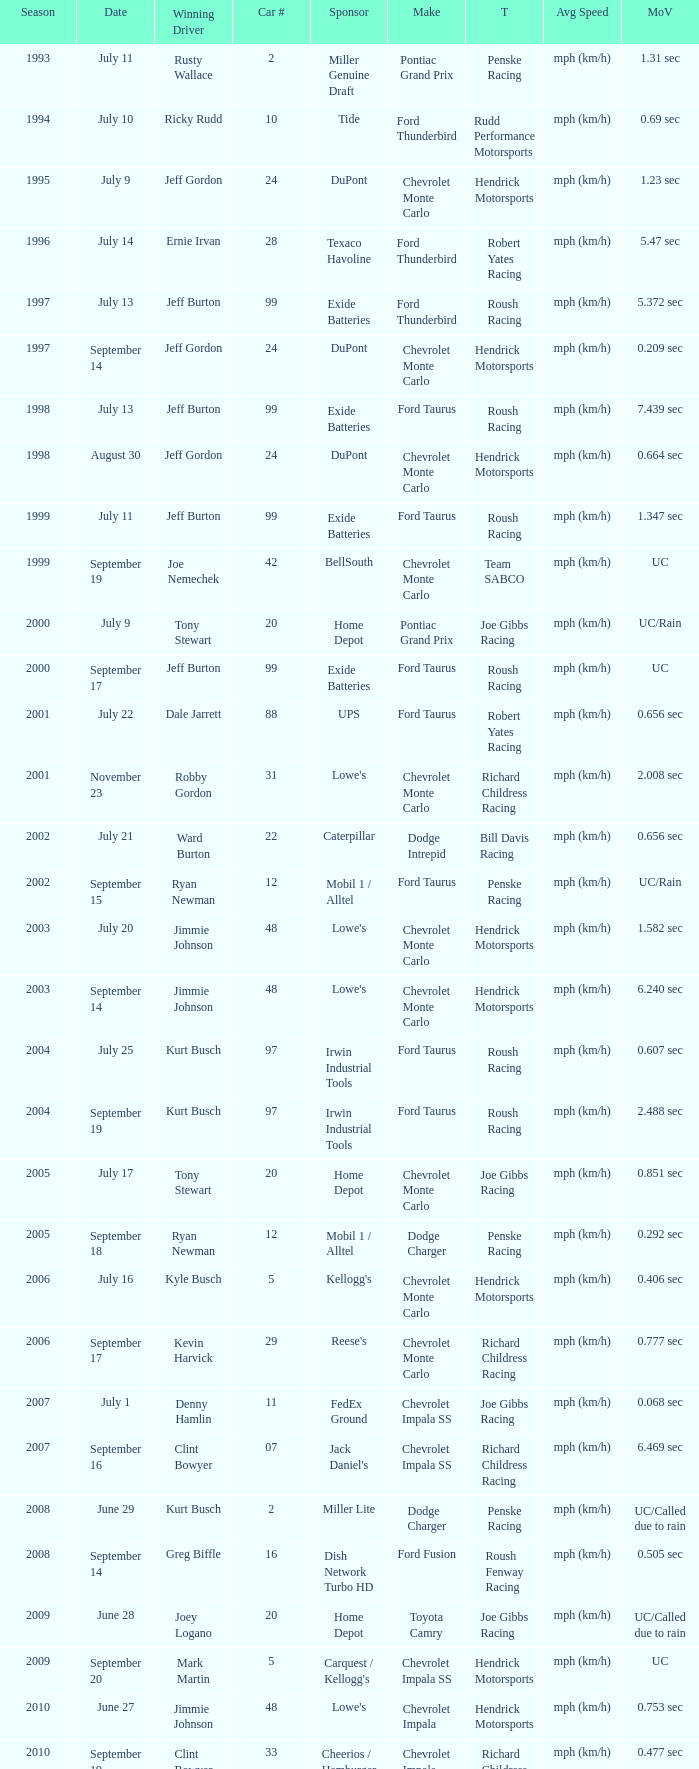What team ran car #24 on August 30? Hendrick Motorsports. 